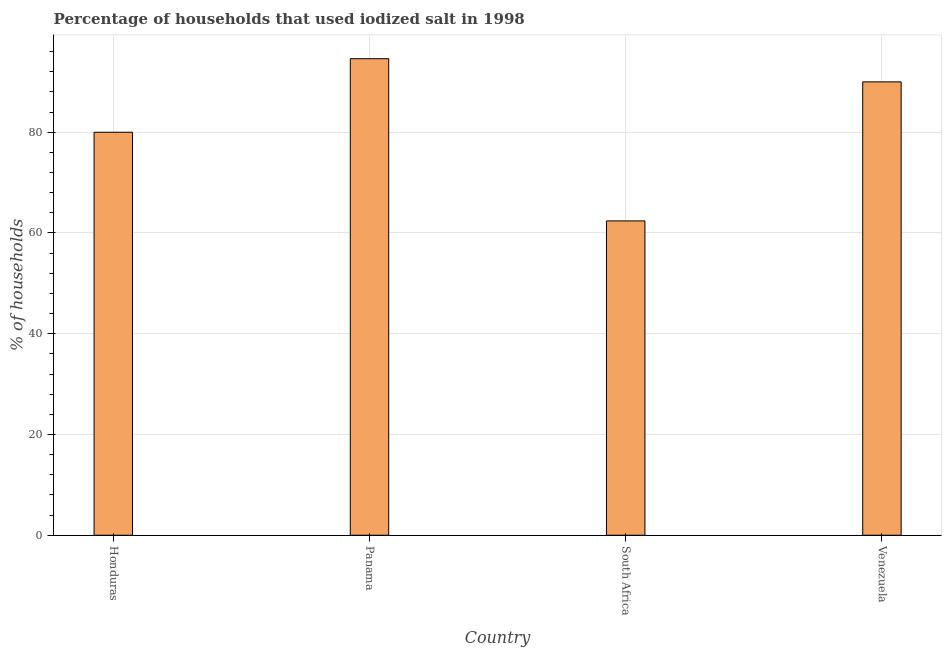Does the graph contain any zero values?
Ensure brevity in your answer.  No. Does the graph contain grids?
Provide a short and direct response. Yes. What is the title of the graph?
Keep it short and to the point. Percentage of households that used iodized salt in 1998. What is the label or title of the X-axis?
Give a very brief answer. Country. What is the label or title of the Y-axis?
Keep it short and to the point. % of households. What is the percentage of households where iodized salt is consumed in South Africa?
Make the answer very short. 62.4. Across all countries, what is the maximum percentage of households where iodized salt is consumed?
Ensure brevity in your answer.  94.6. Across all countries, what is the minimum percentage of households where iodized salt is consumed?
Give a very brief answer. 62.4. In which country was the percentage of households where iodized salt is consumed maximum?
Give a very brief answer. Panama. In which country was the percentage of households where iodized salt is consumed minimum?
Offer a terse response. South Africa. What is the sum of the percentage of households where iodized salt is consumed?
Your response must be concise. 327. What is the difference between the percentage of households where iodized salt is consumed in South Africa and Venezuela?
Keep it short and to the point. -27.6. What is the average percentage of households where iodized salt is consumed per country?
Provide a short and direct response. 81.75. What is the median percentage of households where iodized salt is consumed?
Your answer should be compact. 85. In how many countries, is the percentage of households where iodized salt is consumed greater than 48 %?
Your answer should be very brief. 4. What is the ratio of the percentage of households where iodized salt is consumed in Honduras to that in Panama?
Offer a terse response. 0.85. What is the difference between the highest and the lowest percentage of households where iodized salt is consumed?
Keep it short and to the point. 32.2. How many bars are there?
Your answer should be very brief. 4. How many countries are there in the graph?
Give a very brief answer. 4. What is the difference between two consecutive major ticks on the Y-axis?
Make the answer very short. 20. What is the % of households in Panama?
Provide a succinct answer. 94.6. What is the % of households in South Africa?
Your response must be concise. 62.4. What is the % of households in Venezuela?
Your response must be concise. 90. What is the difference between the % of households in Honduras and Panama?
Keep it short and to the point. -14.6. What is the difference between the % of households in Honduras and South Africa?
Offer a very short reply. 17.6. What is the difference between the % of households in Panama and South Africa?
Provide a short and direct response. 32.2. What is the difference between the % of households in South Africa and Venezuela?
Keep it short and to the point. -27.6. What is the ratio of the % of households in Honduras to that in Panama?
Keep it short and to the point. 0.85. What is the ratio of the % of households in Honduras to that in South Africa?
Offer a very short reply. 1.28. What is the ratio of the % of households in Honduras to that in Venezuela?
Make the answer very short. 0.89. What is the ratio of the % of households in Panama to that in South Africa?
Offer a very short reply. 1.52. What is the ratio of the % of households in Panama to that in Venezuela?
Provide a short and direct response. 1.05. What is the ratio of the % of households in South Africa to that in Venezuela?
Your answer should be very brief. 0.69. 